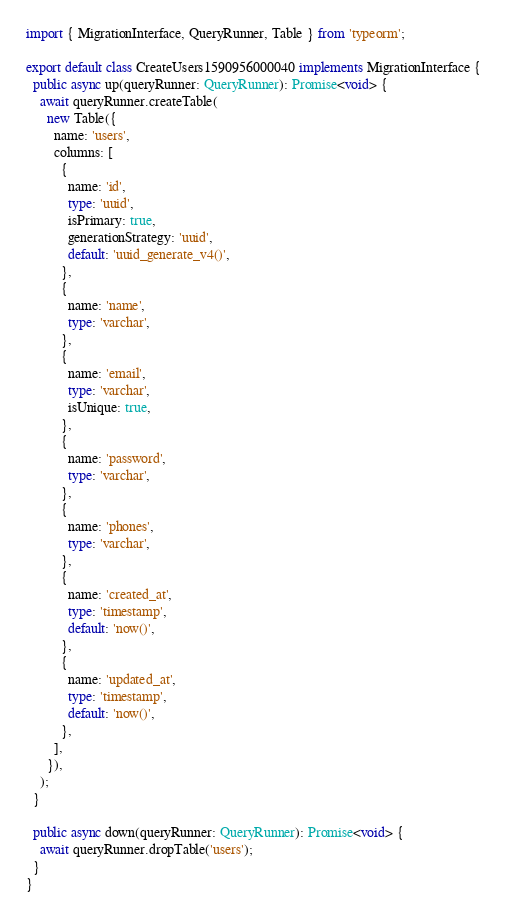<code> <loc_0><loc_0><loc_500><loc_500><_TypeScript_>import { MigrationInterface, QueryRunner, Table } from 'typeorm';

export default class CreateUsers1590956000040 implements MigrationInterface {
  public async up(queryRunner: QueryRunner): Promise<void> {
    await queryRunner.createTable(
      new Table({
        name: 'users',
        columns: [
          {
            name: 'id',
            type: 'uuid',
            isPrimary: true,
            generationStrategy: 'uuid',
            default: 'uuid_generate_v4()',
          },
          {
            name: 'name',
            type: 'varchar',
          },
          {
            name: 'email',
            type: 'varchar',
            isUnique: true,
          },
          {
            name: 'password',
            type: 'varchar',
          },
          {
            name: 'phones',
            type: 'varchar',
          },
          {
            name: 'created_at',
            type: 'timestamp',
            default: 'now()',
          },
          {
            name: 'updated_at',
            type: 'timestamp',
            default: 'now()',
          },
        ],
      }),
    );
  }

  public async down(queryRunner: QueryRunner): Promise<void> {
    await queryRunner.dropTable('users');
  }
}
</code> 